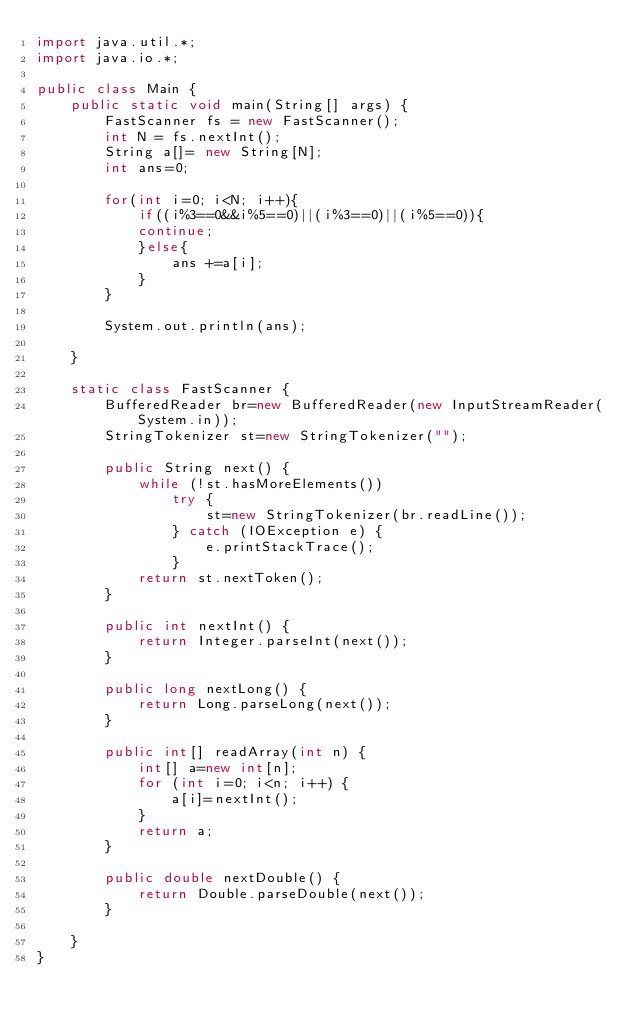<code> <loc_0><loc_0><loc_500><loc_500><_Java_>import java.util.*;
import java.io.*;

public class Main {	
	public static void main(String[] args) {
		FastScanner fs = new FastScanner();
		int N = fs.nextInt();
		String a[]= new String[N];
		int ans=0;
		
		for(int i=0; i<N; i++){
			if((i%3==0&&i%5==0)||(i%3==0)||(i%5==0)){
			continue;
			}else{
				ans +=a[i];
			}
		}
		
		System.out.println(ans);

	}

	static class FastScanner {
		BufferedReader br=new BufferedReader(new InputStreamReader(System.in));
		StringTokenizer st=new StringTokenizer("");

		public String next() {
			while (!st.hasMoreElements())
				try {
					st=new StringTokenizer(br.readLine());
				} catch (IOException e) {
					e.printStackTrace();
				}
			return st.nextToken();
		}

		public int nextInt() {
			return Integer.parseInt(next());
		}

		public long nextLong() {
			return Long.parseLong(next());
		}

		public int[] readArray(int n) {
			int[] a=new int[n];
			for (int i=0; i<n; i++) {
				a[i]=nextInt();
			}
			return a;
		}

		public double nextDouble() {
			return Double.parseDouble(next());
		}

	}
}
</code> 